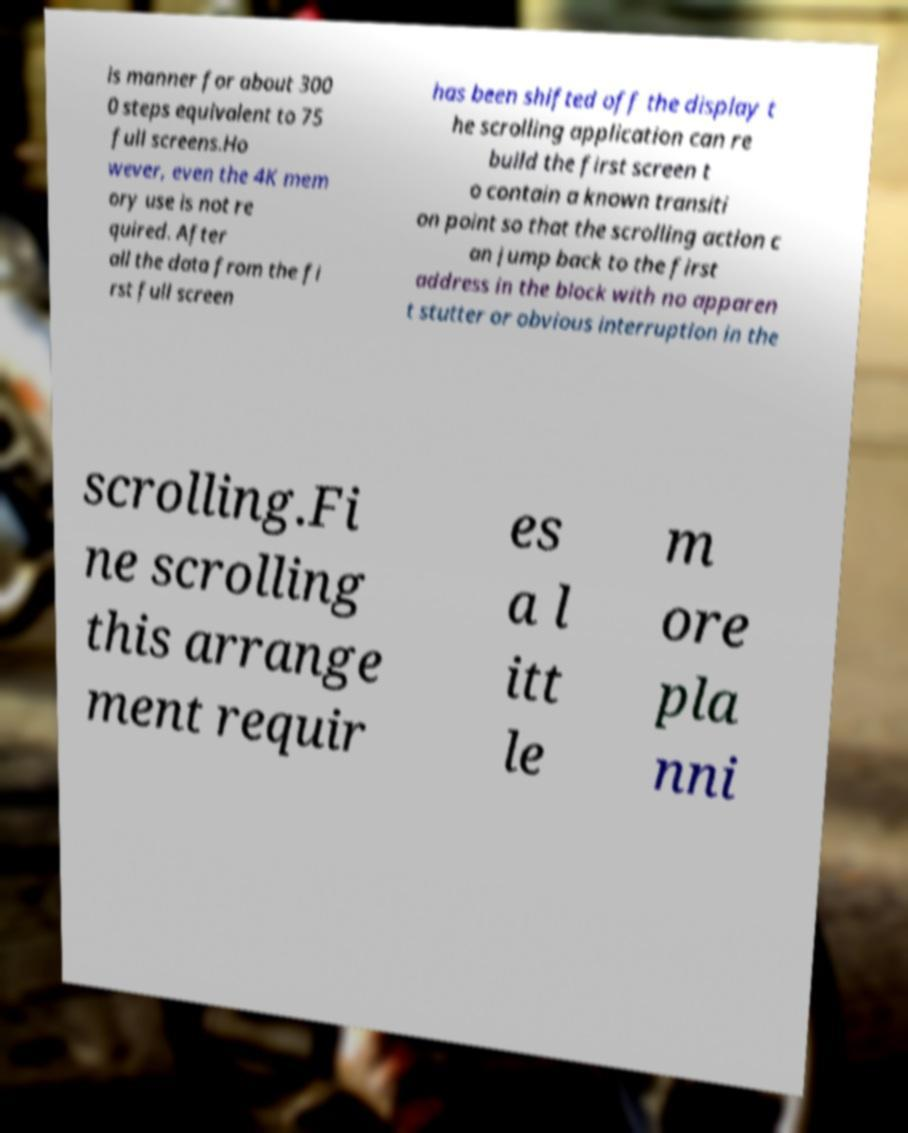Can you read and provide the text displayed in the image?This photo seems to have some interesting text. Can you extract and type it out for me? is manner for about 300 0 steps equivalent to 75 full screens.Ho wever, even the 4K mem ory use is not re quired. After all the data from the fi rst full screen has been shifted off the display t he scrolling application can re build the first screen t o contain a known transiti on point so that the scrolling action c an jump back to the first address in the block with no apparen t stutter or obvious interruption in the scrolling.Fi ne scrolling this arrange ment requir es a l itt le m ore pla nni 